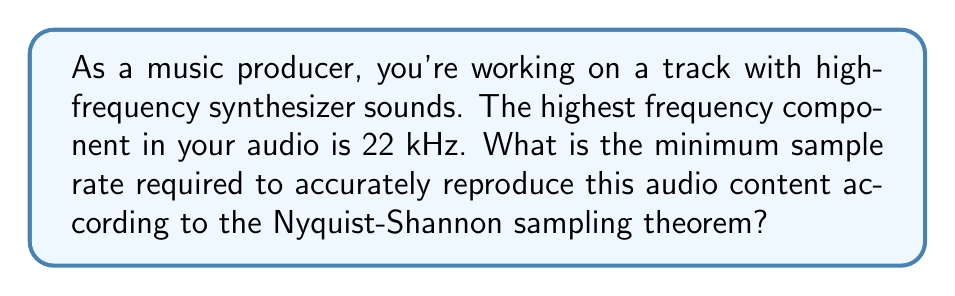What is the answer to this math problem? To solve this problem, we'll use the Nyquist-Shannon sampling theorem. This theorem states that to accurately reproduce a signal, the sampling rate must be at least twice the highest frequency component in the signal. Let's follow these steps:

1. Identify the highest frequency component:
   $f_{max} = 22 \text{ kHz} = 22,000 \text{ Hz}$

2. Apply the Nyquist-Shannon sampling theorem:
   $$f_s \geq 2 \cdot f_{max}$$
   Where $f_s$ is the sampling rate.

3. Calculate the minimum sampling rate:
   $$f_s \geq 2 \cdot 22,000 \text{ Hz}$$
   $$f_s \geq 44,000 \text{ Hz}$$

4. Round up to the nearest standard sample rate:
   The closest standard sample rate above 44,000 Hz is 44.1 kHz, which is commonly used in digital audio.

Therefore, the minimum sample rate required to accurately reproduce the audio content with a highest frequency component of 22 kHz is 44.1 kHz.
Answer: 44.1 kHz 